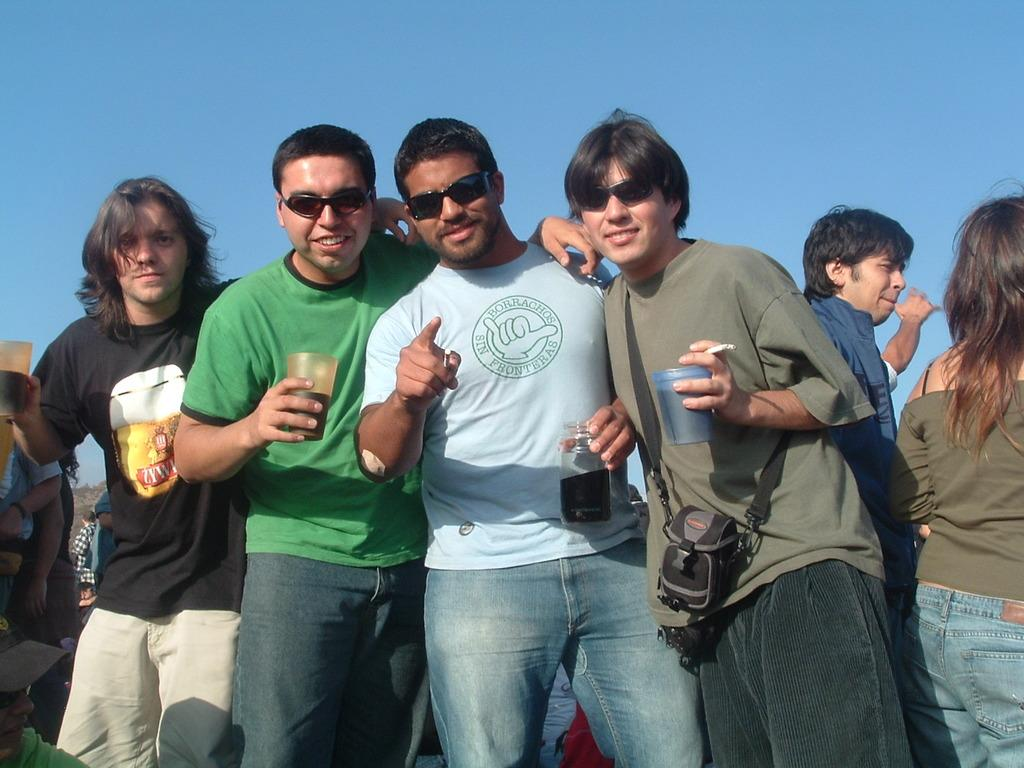What are the people in the image doing? There are people standing in the image. What are some of the people holding in their hands? Some of the people are holding glasses in their hands. How many people are wearing black color shades? Three people are wearing black color shades. What can be seen in the background of the image? The sky is visible in the background of the image. What type of monkey can be seen climbing on the people in the image? There is no monkey present in the image; it only features people standing and holding glasses. What is the texture of the letters on the people's shirts in the image? There are no letters visible on the people's shirts in the image. 